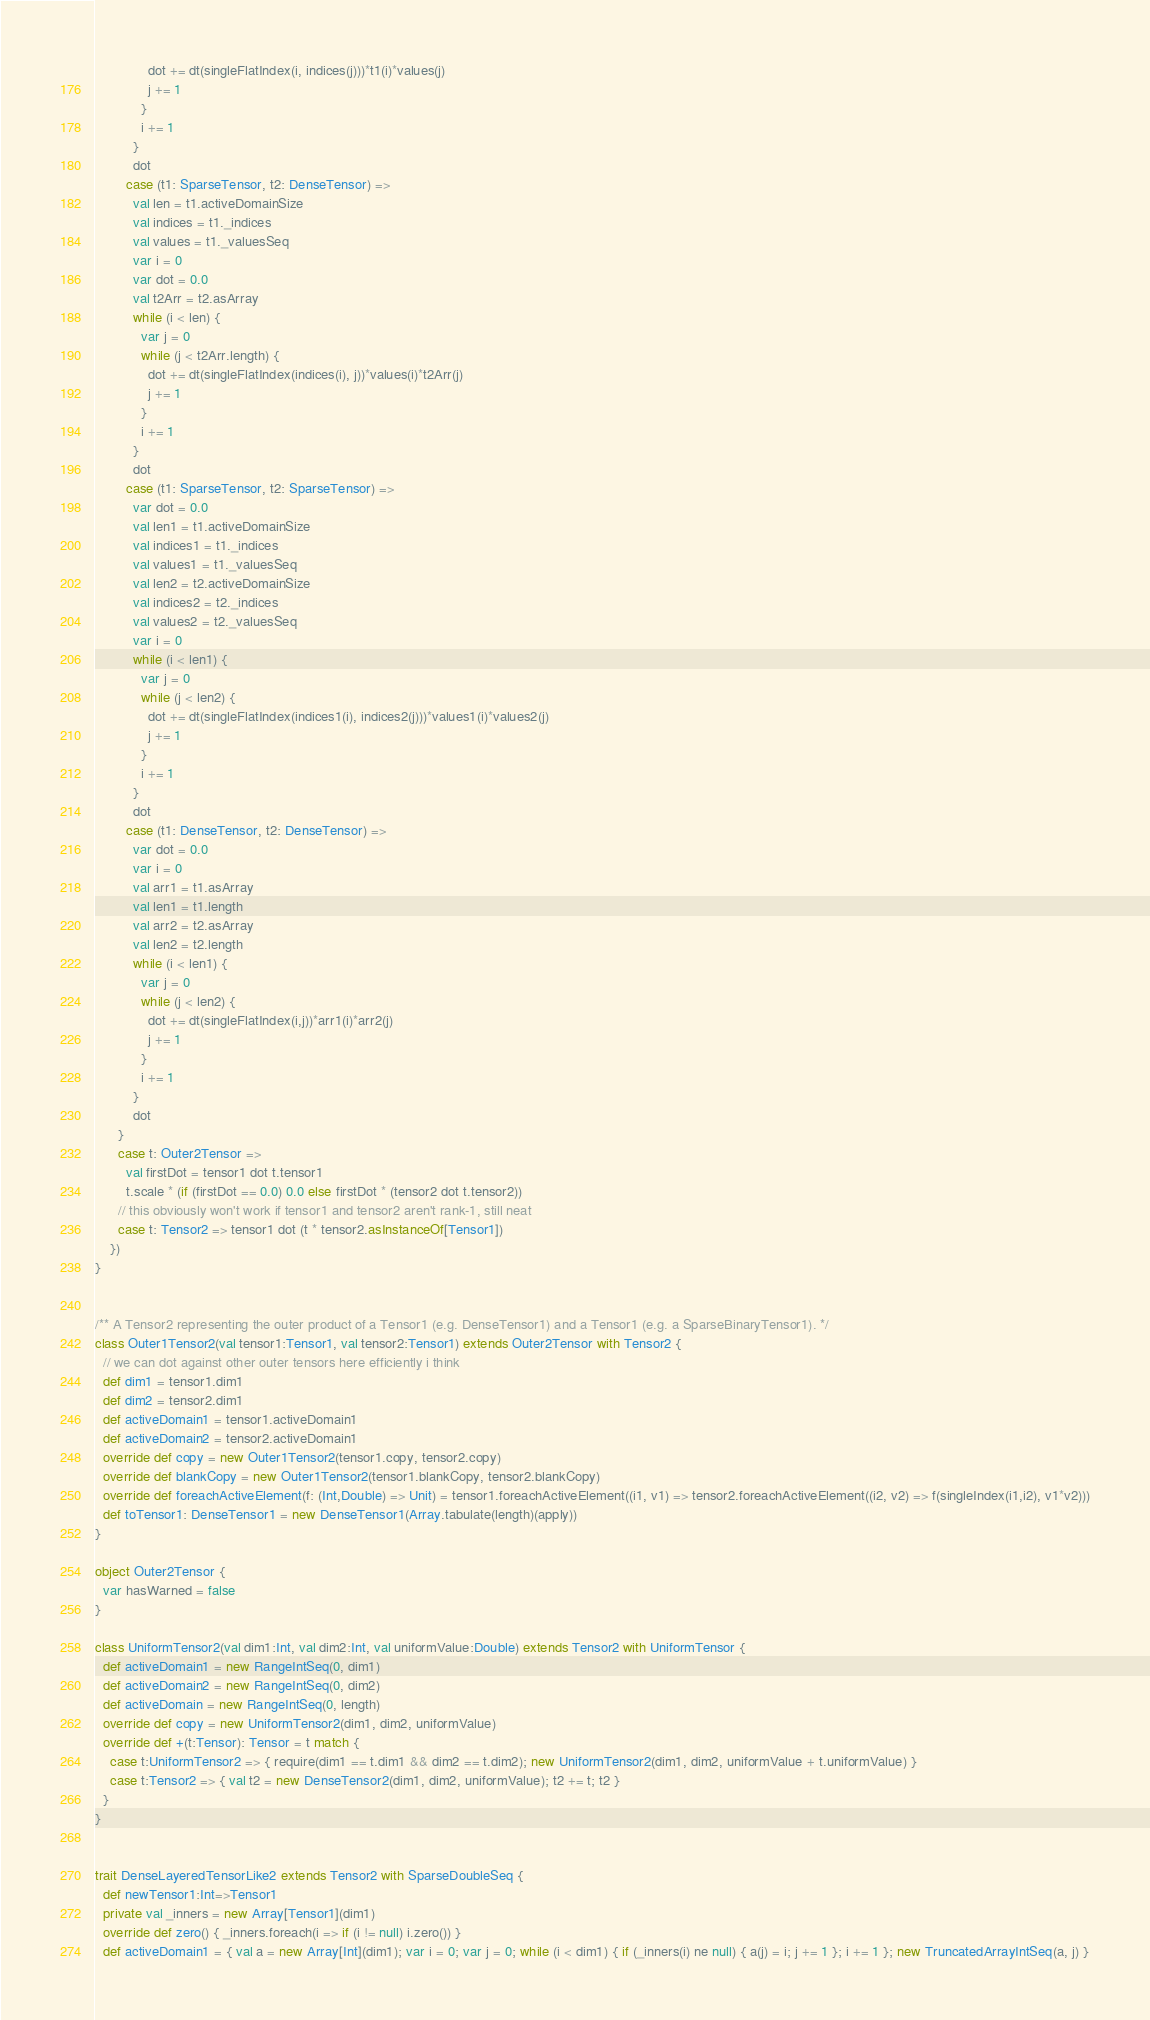Convert code to text. <code><loc_0><loc_0><loc_500><loc_500><_Scala_>              dot += dt(singleFlatIndex(i, indices(j)))*t1(i)*values(j)
              j += 1
            }
            i += 1
          }
          dot
        case (t1: SparseTensor, t2: DenseTensor) =>
          val len = t1.activeDomainSize
          val indices = t1._indices
          val values = t1._valuesSeq
          var i = 0
          var dot = 0.0
          val t2Arr = t2.asArray
          while (i < len) {
            var j = 0
            while (j < t2Arr.length) {
              dot += dt(singleFlatIndex(indices(i), j))*values(i)*t2Arr(j)
              j += 1
            }
            i += 1
          }
          dot
        case (t1: SparseTensor, t2: SparseTensor) =>
          var dot = 0.0
          val len1 = t1.activeDomainSize
          val indices1 = t1._indices
          val values1 = t1._valuesSeq
          val len2 = t2.activeDomainSize
          val indices2 = t2._indices
          val values2 = t2._valuesSeq
          var i = 0
          while (i < len1) {
            var j = 0
            while (j < len2) {
              dot += dt(singleFlatIndex(indices1(i), indices2(j)))*values1(i)*values2(j)
              j += 1
            }
            i += 1
          }
          dot
        case (t1: DenseTensor, t2: DenseTensor) =>
          var dot = 0.0
          var i = 0
          val arr1 = t1.asArray
          val len1 = t1.length
          val arr2 = t2.asArray
          val len2 = t2.length
          while (i < len1) {
            var j = 0
            while (j < len2) {
              dot += dt(singleFlatIndex(i,j))*arr1(i)*arr2(j)
              j += 1
            }
            i += 1
          }
          dot
      }
      case t: Outer2Tensor =>
        val firstDot = tensor1 dot t.tensor1
        t.scale * (if (firstDot == 0.0) 0.0 else firstDot * (tensor2 dot t.tensor2))
      // this obviously won't work if tensor1 and tensor2 aren't rank-1, still neat
      case t: Tensor2 => tensor1 dot (t * tensor2.asInstanceOf[Tensor1])
    })
}


/** A Tensor2 representing the outer product of a Tensor1 (e.g. DenseTensor1) and a Tensor1 (e.g. a SparseBinaryTensor1). */
class Outer1Tensor2(val tensor1:Tensor1, val tensor2:Tensor1) extends Outer2Tensor with Tensor2 {
  // we can dot against other outer tensors here efficiently i think
  def dim1 = tensor1.dim1
  def dim2 = tensor2.dim1
  def activeDomain1 = tensor1.activeDomain1
  def activeDomain2 = tensor2.activeDomain1
  override def copy = new Outer1Tensor2(tensor1.copy, tensor2.copy)
  override def blankCopy = new Outer1Tensor2(tensor1.blankCopy, tensor2.blankCopy)
  override def foreachActiveElement(f: (Int,Double) => Unit) = tensor1.foreachActiveElement((i1, v1) => tensor2.foreachActiveElement((i2, v2) => f(singleIndex(i1,i2), v1*v2)))
  def toTensor1: DenseTensor1 = new DenseTensor1(Array.tabulate(length)(apply))
}

object Outer2Tensor {
  var hasWarned = false
}

class UniformTensor2(val dim1:Int, val dim2:Int, val uniformValue:Double) extends Tensor2 with UniformTensor {
  def activeDomain1 = new RangeIntSeq(0, dim1)
  def activeDomain2 = new RangeIntSeq(0, dim2)
  def activeDomain = new RangeIntSeq(0, length)
  override def copy = new UniformTensor2(dim1, dim2, uniformValue)
  override def +(t:Tensor): Tensor = t match {
    case t:UniformTensor2 => { require(dim1 == t.dim1 && dim2 == t.dim2); new UniformTensor2(dim1, dim2, uniformValue + t.uniformValue) }
    case t:Tensor2 => { val t2 = new DenseTensor2(dim1, dim2, uniformValue); t2 += t; t2 }
  }
}


trait DenseLayeredTensorLike2 extends Tensor2 with SparseDoubleSeq {
  def newTensor1:Int=>Tensor1
  private val _inners = new Array[Tensor1](dim1)
  override def zero() { _inners.foreach(i => if (i != null) i.zero()) }
  def activeDomain1 = { val a = new Array[Int](dim1); var i = 0; var j = 0; while (i < dim1) { if (_inners(i) ne null) { a(j) = i; j += 1 }; i += 1 }; new TruncatedArrayIntSeq(a, j) }</code> 